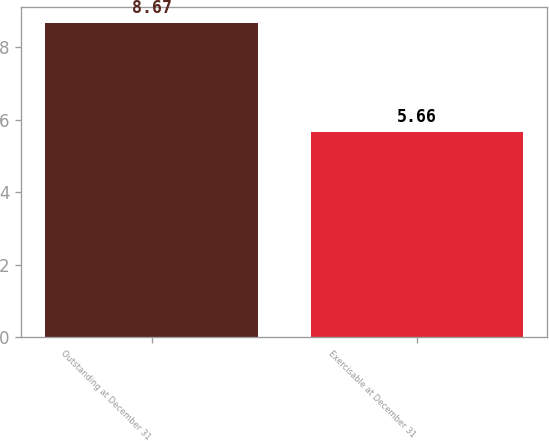<chart> <loc_0><loc_0><loc_500><loc_500><bar_chart><fcel>Outstanding at December 31<fcel>Exercisable at December 31<nl><fcel>8.67<fcel>5.66<nl></chart> 